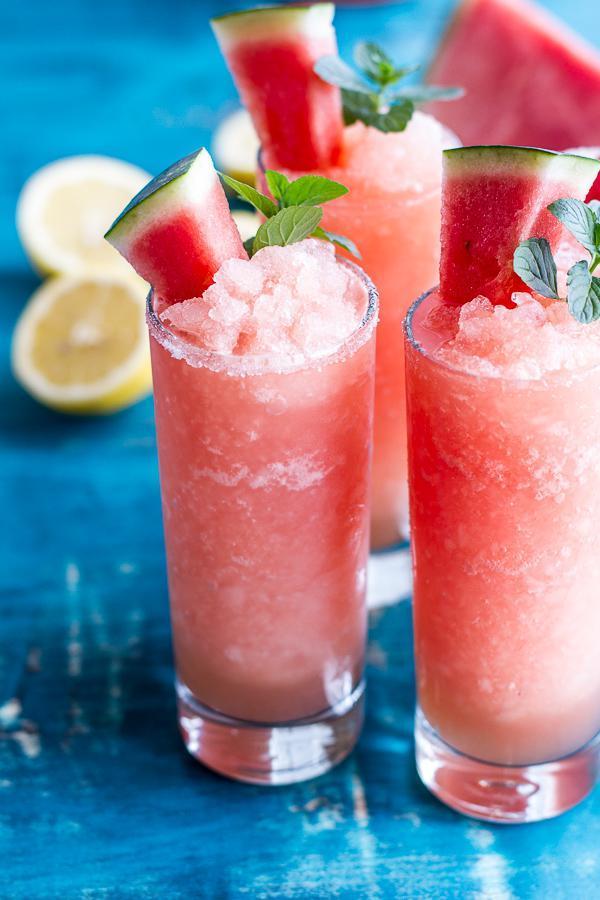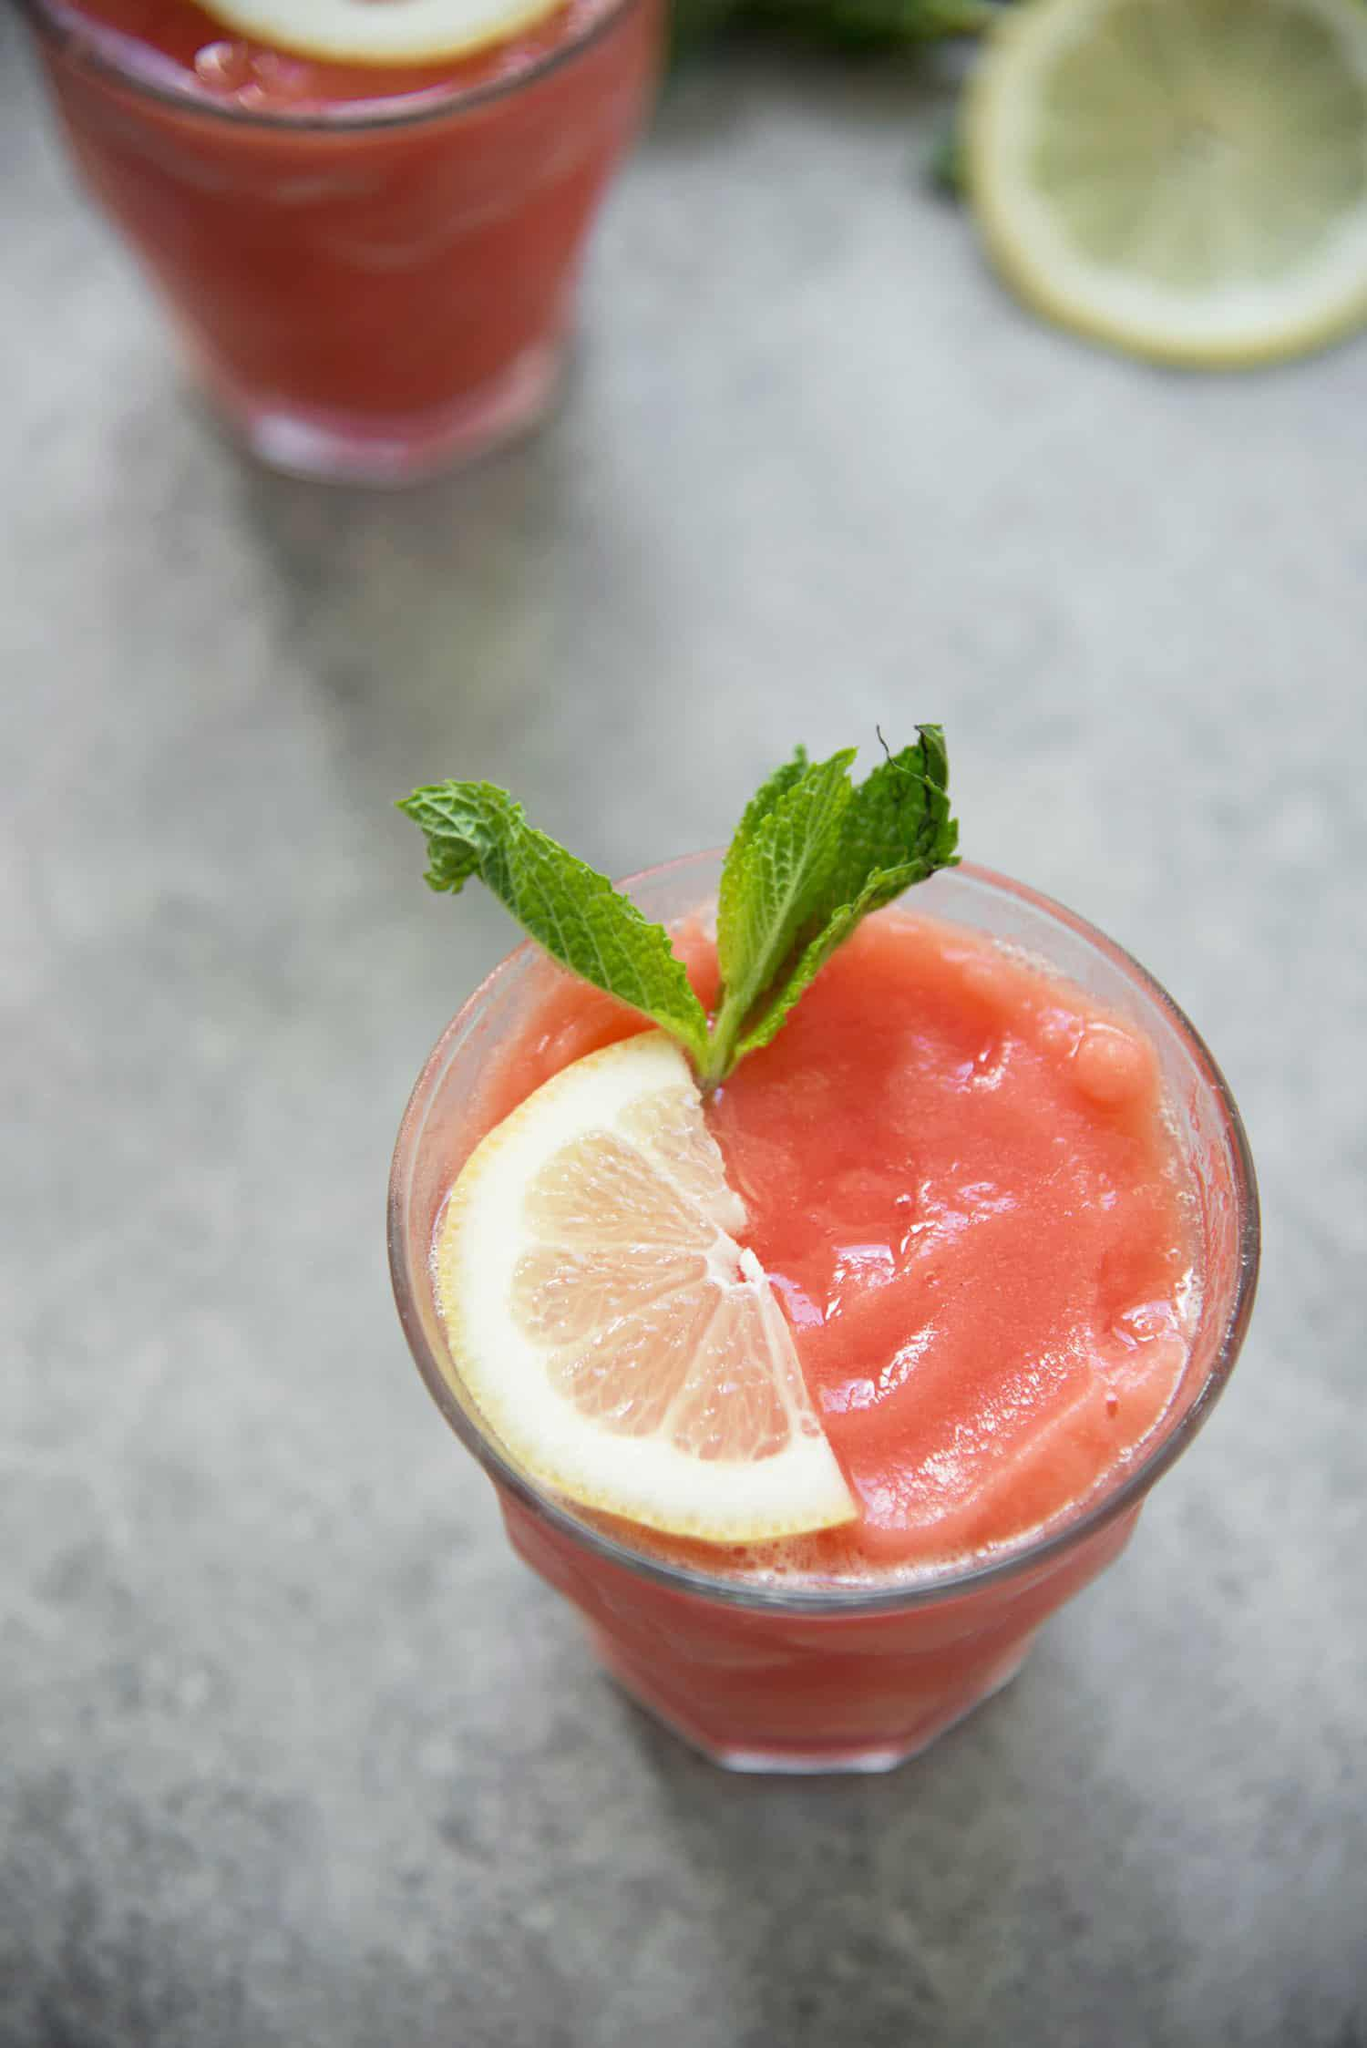The first image is the image on the left, the second image is the image on the right. Examine the images to the left and right. Is the description "There are no more than 5 full drink glasses." accurate? Answer yes or no. Yes. 